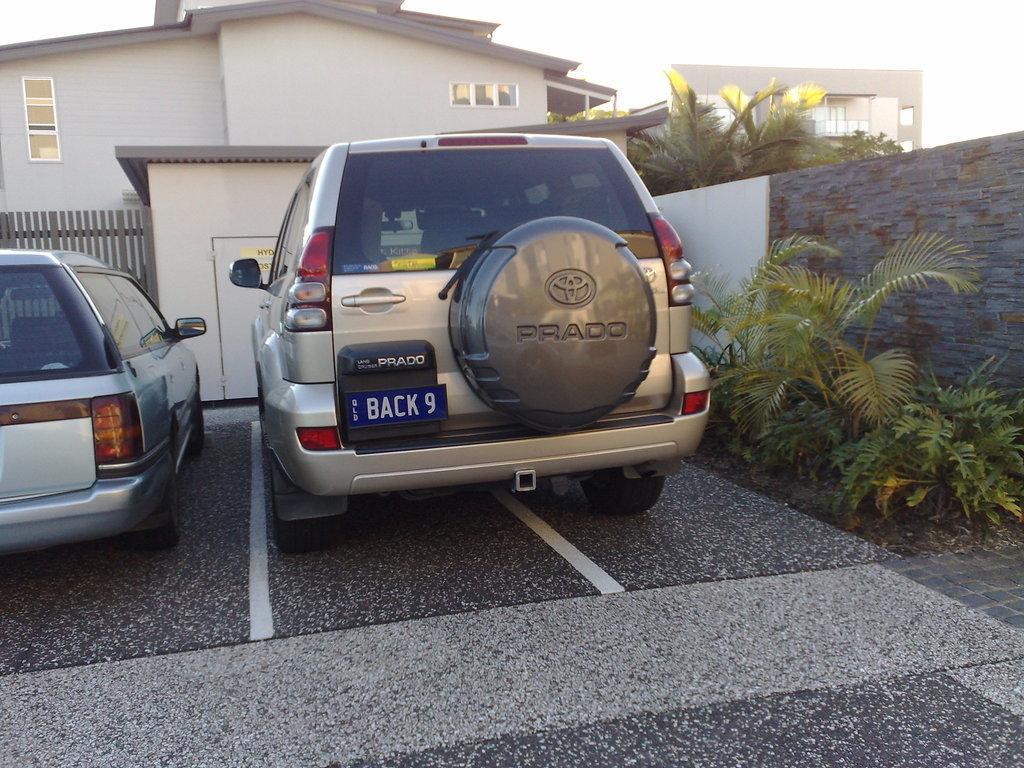Can you describe this image briefly? In this image we can see two cars parked in the parking lot. In the background we can see group of buildings ,trees and plants and the sky. 